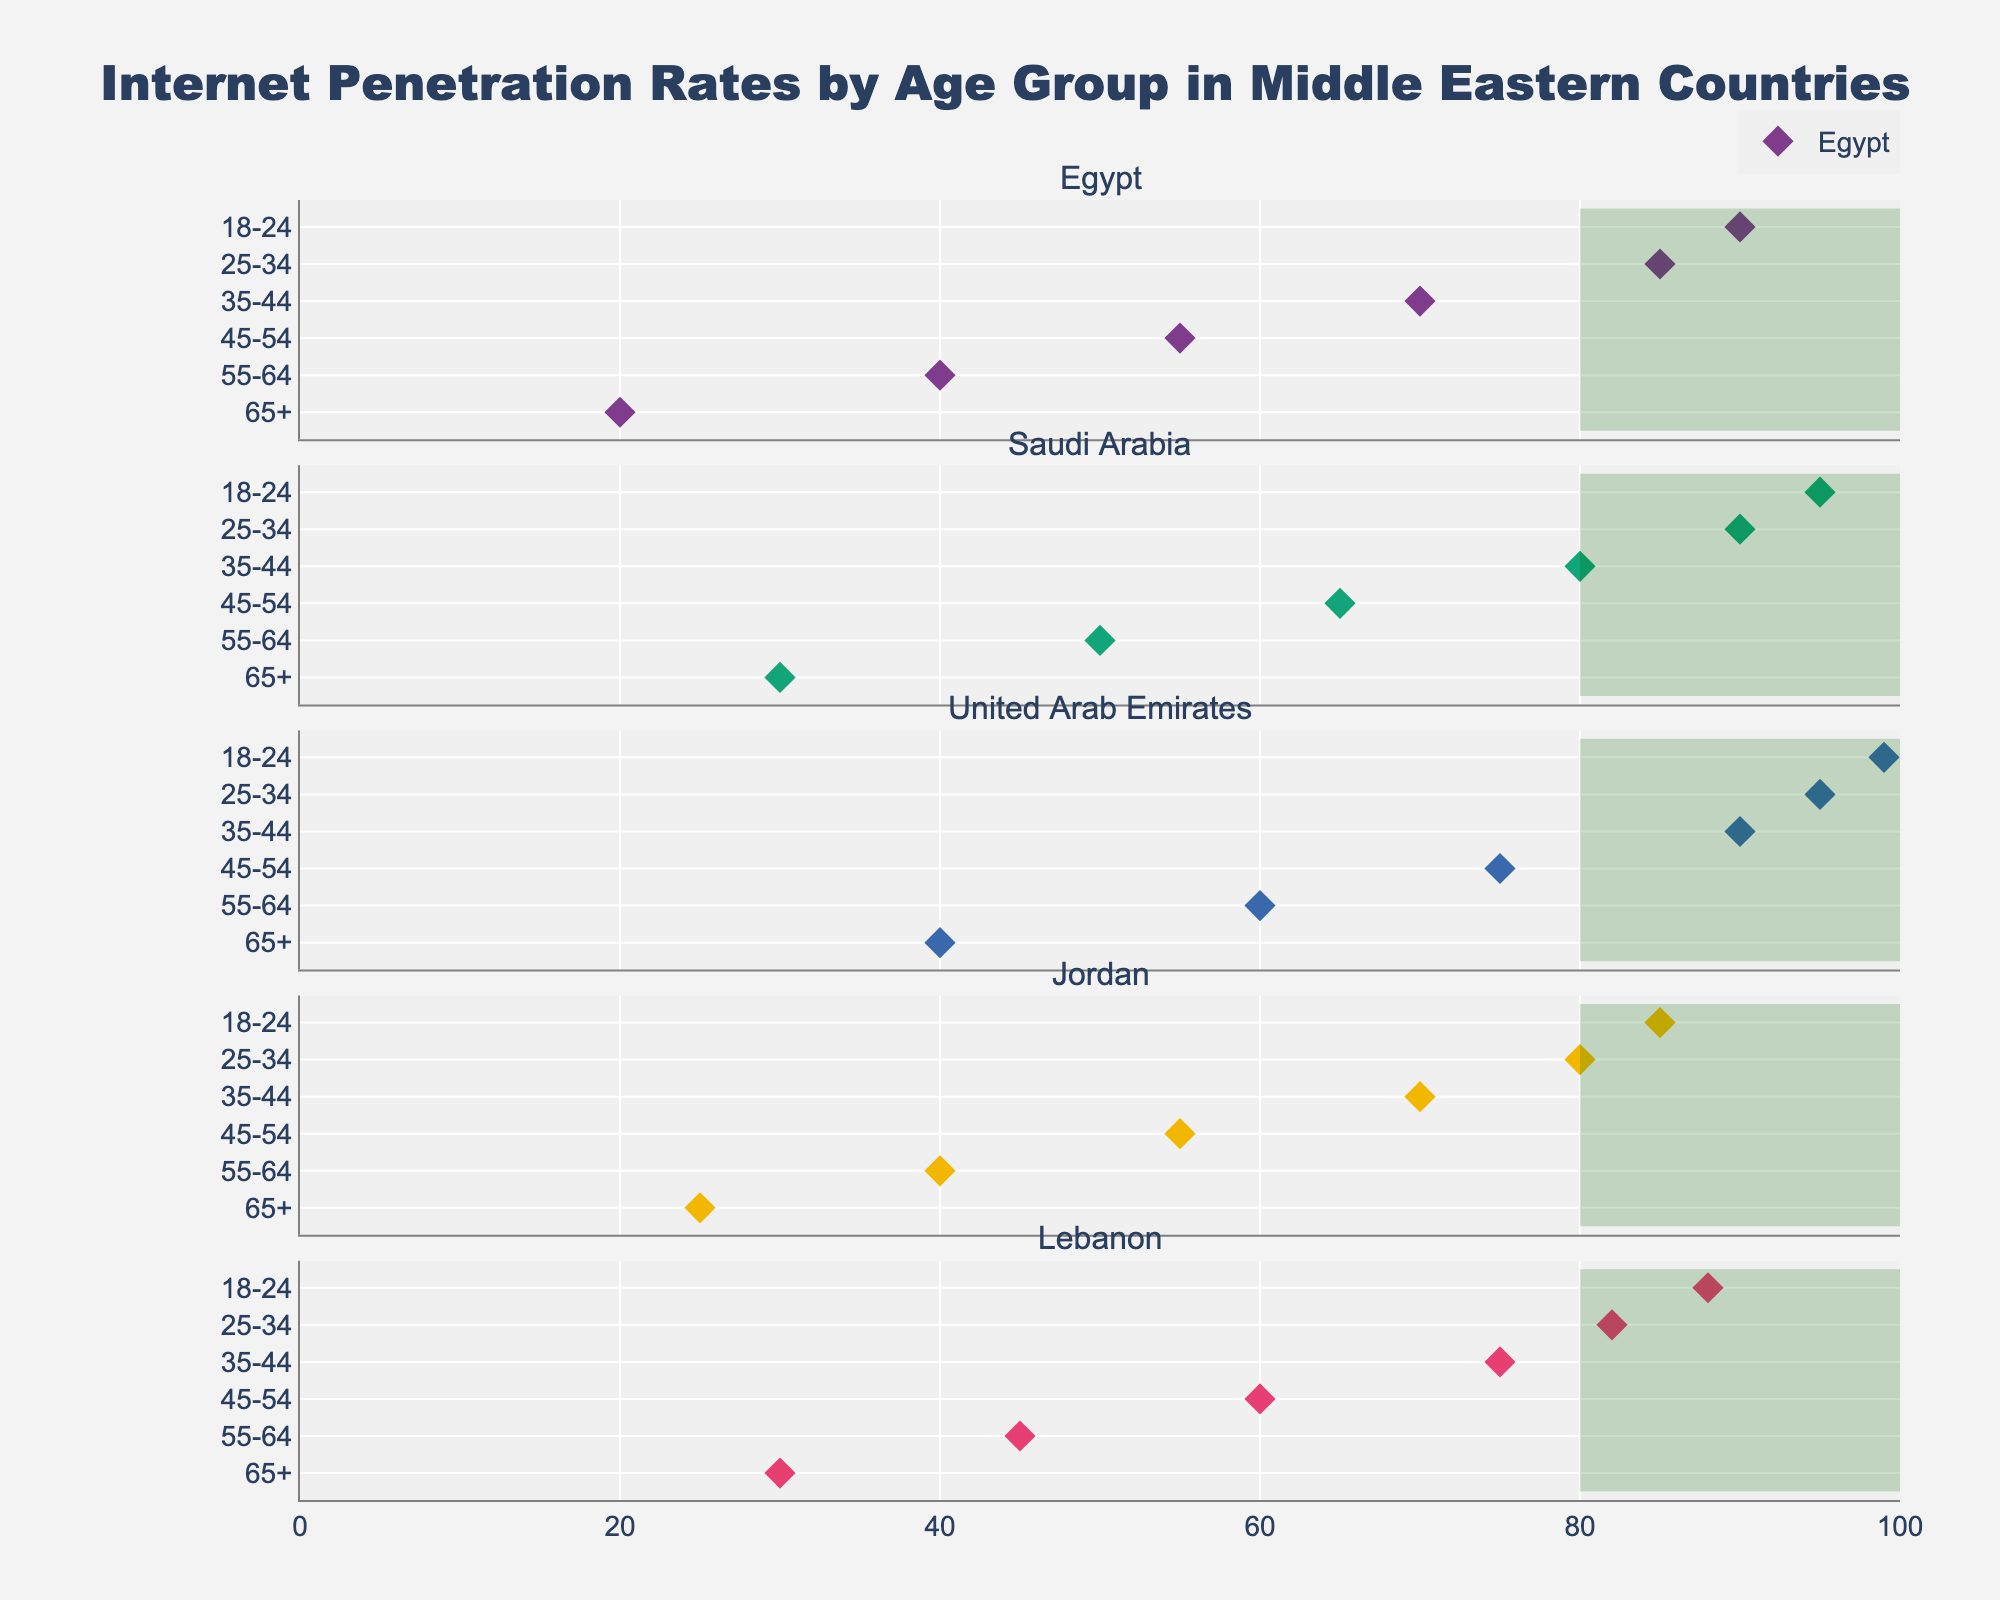What is the title of the figure? The title is usually displayed at the top of the plot in a larger or bolder font compared to other text elements. The title of this figure is "Internet Penetration Rates by Age Group in Middle Eastern Countries."
Answer: Internet Penetration Rates by Age Group in Middle Eastern Countries Which country has the highest internet penetration rate for the 18-24 age group? Look at the markers along the x-axis for the 18-24 age group row and identify the highest value. The United Arab Emirates has the highest rate at 99%.
Answer: United Arab Emirates What is the average internet penetration rate for the 65+ age group in Jordan and Lebanon? Look at the markers for the 65+ age group for both Jordan and Lebanon. Jordan's rate is 25% and Lebanon's rate is 30%. The average is (25 + 30) / 2.
Answer: 27.5% Which age group has the smallest variation in internet penetration rates across all countries? Compare the range of internet penetration rates (the difference between the highest and lowest values) across each age group. The 35-44 age group ranges from 70% (Jordan) to 90% (United Arab Emirates), which has a relatively small range compared to others.
Answer: 35-44 age group What is the difference in internet penetration rates between the 18-24 and 65+ age groups in Saudi Arabia? Find the rates for the 18-24 age group (95%) and 65+ age group (30%) in Saudi Arabia. The difference is 95% - 30%.
Answer: 65% Which country has the lowest internet penetration rate for the 55-64 age group? Look along the x-axis for the 55-64 age group row and identify the lowest value. Egypt has the lowest rate at 40%.
Answer: Egypt How many countries have at least one age group with an internet penetration rate above 90%? Identify the countries with at least one marker at or above 90%. The countries are Egypt (one group), Saudi Arabia (two groups), and the United Arab Emirates (all groups), making it three countries.
Answer: 3 For which country does the 25-34 age group and the 35-44 age group have exactly a 10% difference in internet penetration rates? Look at the 25-34 and 35-44 age group markers for each country and check if their difference is exactly 10%. Lebanon has 82% (25-34) and 75% (35-44), which differ by 7%. Saudi Arabia has 90% (25-34) and 80% (35-44), which is exactly 10%.
Answer: Saudi Arabia 